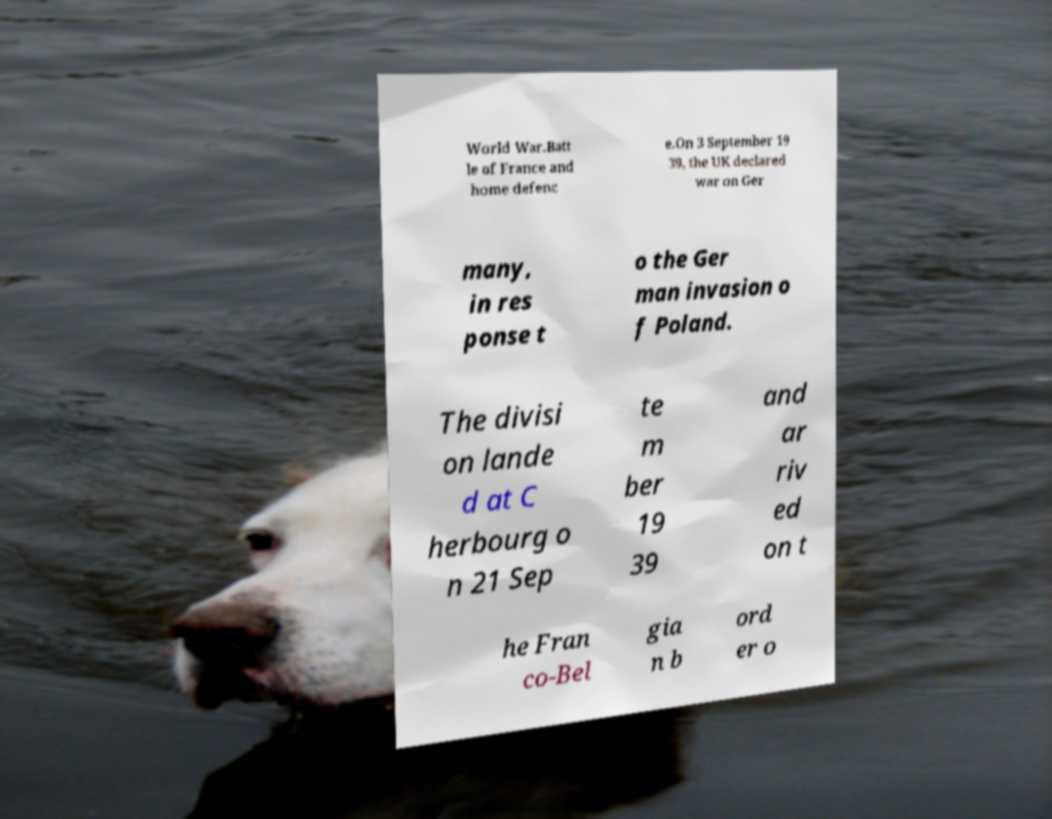I need the written content from this picture converted into text. Can you do that? World War.Batt le of France and home defenc e.On 3 September 19 39, the UK declared war on Ger many, in res ponse t o the Ger man invasion o f Poland. The divisi on lande d at C herbourg o n 21 Sep te m ber 19 39 and ar riv ed on t he Fran co-Bel gia n b ord er o 